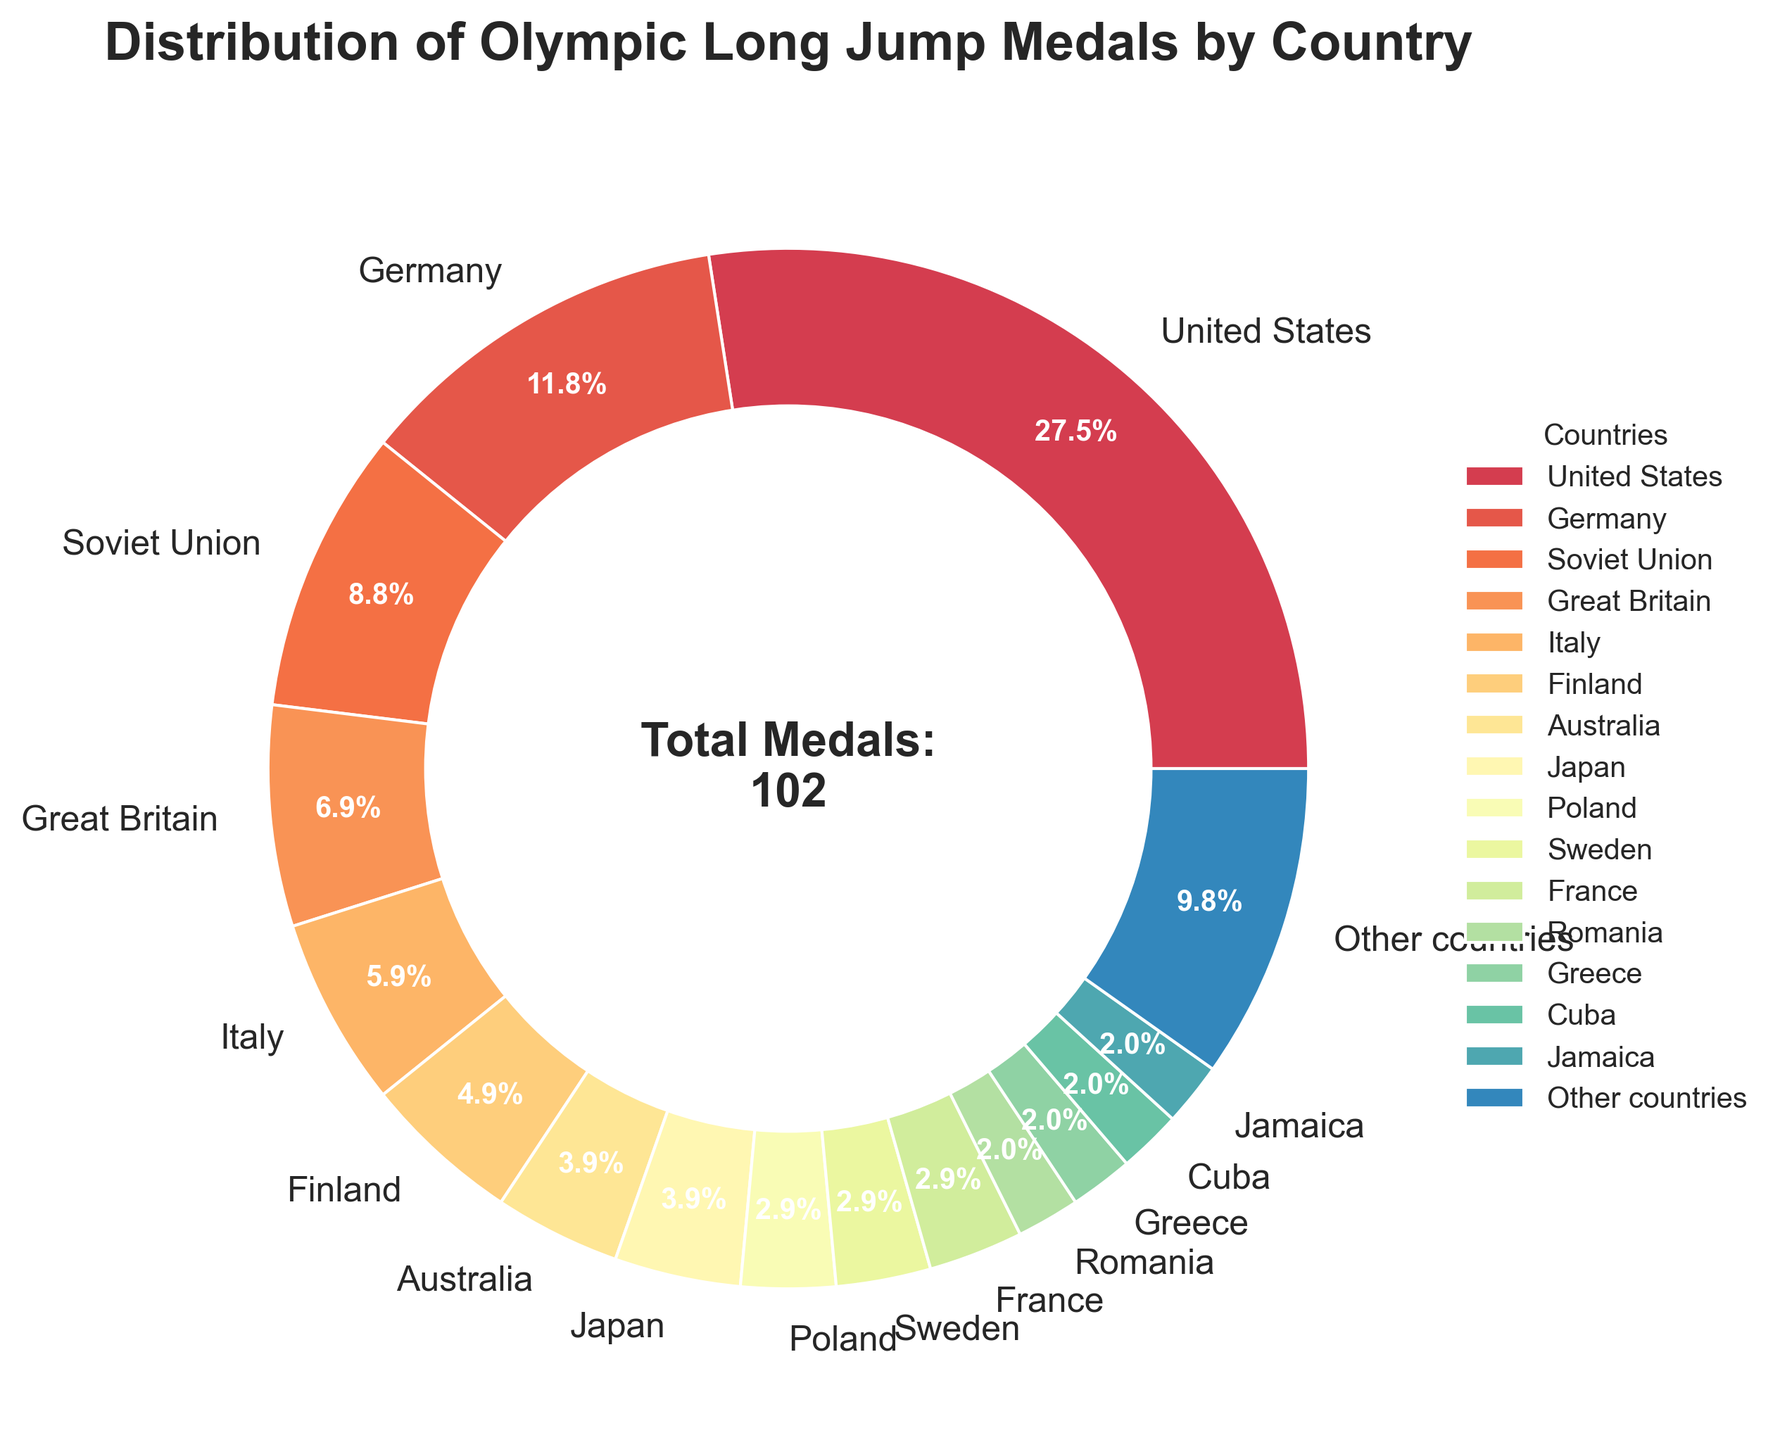What's the country with the highest number of Olympic long jump medals? The slice that takes up the largest portion of the pie chart is labeled "United States," indicating it has the highest number of medals.
Answer: United States Which country has more Olympic long jump medals, Germany or Soviet Union? By comparing the sizes of the slices for Germany and the Soviet Union, it's clear that Germany has a slightly larger slice.
Answer: Germany What percent of the total Olympic long jump medals has been won by other countries (excluding the specific countries listed)? The pie slice labeled "Other countries" has a percentage written on it, which represents the medals won by countries that are not listed individually.
Answer: 9.8% Add the total number of medals won by Great Britain, Italy, and Finland. The individual medal counts for the three countries are given on their respective slices: Great Britain 7, Italy 6, and Finland 5. The sum is 7+6+5 = 18.
Answer: 18 Which country has the smallest slice in the pie chart? The smallest slices appear to belong to Romania, Greece, Cuba, and Jamaica, each with 2 medals.
Answer: Romania, Greece, Cuba, Jamaica Compare the combined medal count of Japan and Australia to that of the Soviet Union. Japan and Australia have 4 medals each, combining for 4+4=8 medals. The Soviet Union has 9 medals, which is one more.
Answer: Soviet Union What is the total number of medals represented in the pie chart? The total number of medals is written at the center of the pie chart along with the text "Total Medals: 102".
Answer: 102 What fraction of the total Olympic long jump medals has been won by the United States? The United States has won 28 medals out of the total 102. The fraction is 28/102, which simplifies to approximately 0.2745.
Answer: 28/102 Which country has an equal number of medals as Sweden? The slice sizes and labels show that France also has 3 medals, which is equal to Sweden's medal count.
Answer: France 